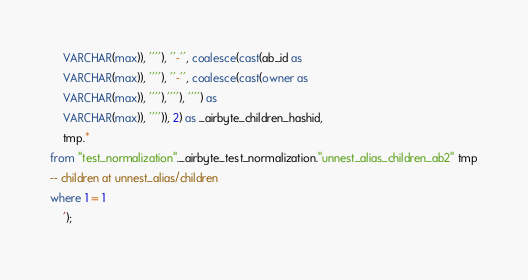Convert code to text. <code><loc_0><loc_0><loc_500><loc_500><_SQL_>    VARCHAR(max)), ''''), ''-'', coalesce(cast(ab_id as 
    VARCHAR(max)), ''''), ''-'', coalesce(cast(owner as 
    VARCHAR(max)), ''''),''''), '''') as 
    VARCHAR(max)), '''')), 2) as _airbyte_children_hashid,
    tmp.*
from "test_normalization"._airbyte_test_normalization."unnest_alias_children_ab2" tmp
-- children at unnest_alias/children
where 1 = 1
    ');

</code> 